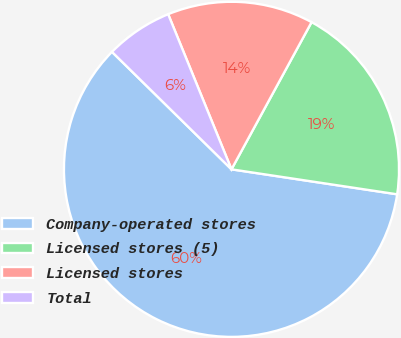Convert chart to OTSL. <chart><loc_0><loc_0><loc_500><loc_500><pie_chart><fcel>Company-operated stores<fcel>Licensed stores (5)<fcel>Licensed stores<fcel>Total<nl><fcel>59.98%<fcel>19.45%<fcel>14.1%<fcel>6.47%<nl></chart> 